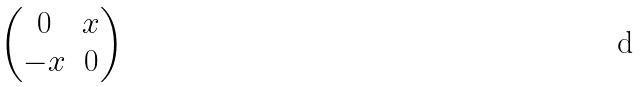<formula> <loc_0><loc_0><loc_500><loc_500>\begin{pmatrix} 0 & x \\ - x & 0 \end{pmatrix}</formula> 